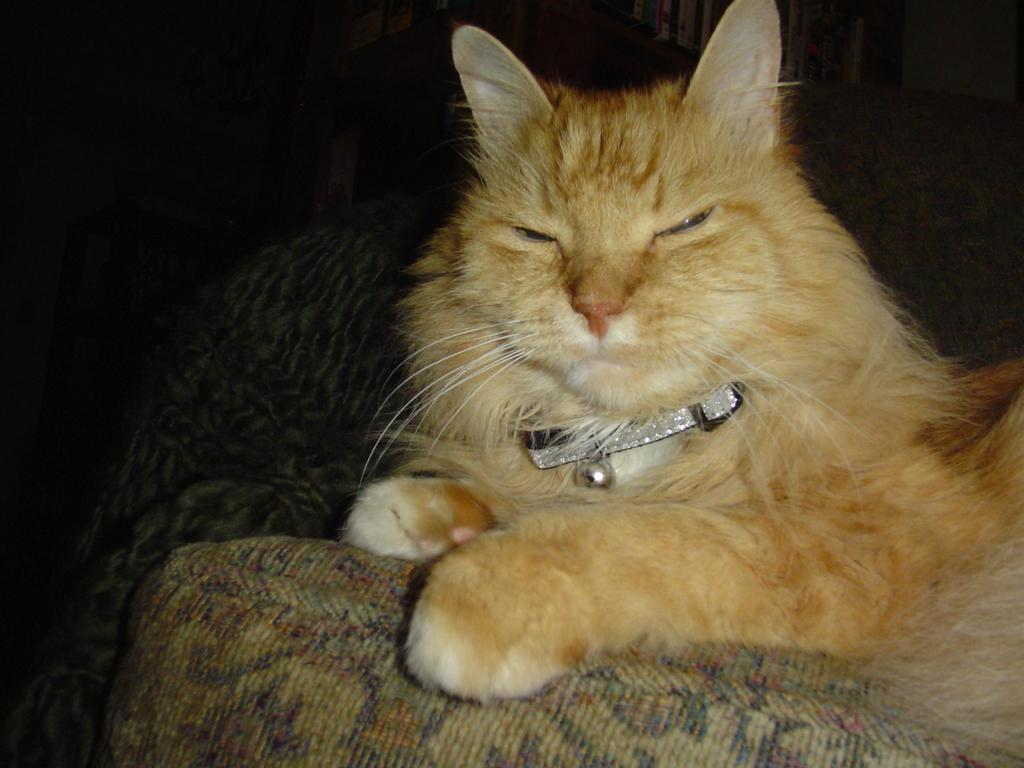What type of animal is in the image? There is a cat in the image. What can be observed about the background of the image? The background of the image is dark. What type of yoke is the cat holding in the image? There is no yoke present in the image; it features a cat with a dark background. 